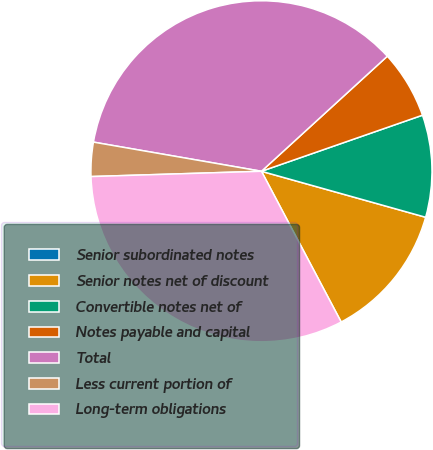<chart> <loc_0><loc_0><loc_500><loc_500><pie_chart><fcel>Senior subordinated notes<fcel>Senior notes net of discount<fcel>Convertible notes net of<fcel>Notes payable and capital<fcel>Total<fcel>Less current portion of<fcel>Long-term obligations<nl><fcel>0.0%<fcel>12.91%<fcel>9.68%<fcel>6.45%<fcel>35.48%<fcel>3.23%<fcel>32.25%<nl></chart> 